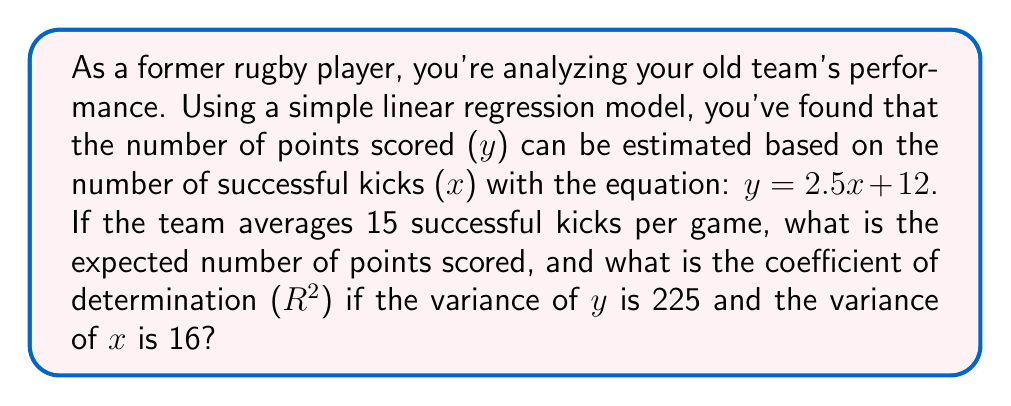Give your solution to this math problem. 1. Calculate the expected number of points:
   - Use the equation $y = 2.5x + 12$
   - Substitute $x = 15$ (average successful kicks)
   $$y = 2.5(15) + 12 = 37.5 + 12 = 49.5$$

2. Calculate the coefficient of determination ($R^2$):
   - The formula for $R^2$ in simple linear regression is:
     $$R^2 = \frac{(Cov(x,y))^2}{Var(x)Var(y)}$$

   - We know $Var(y) = 225$ and $Var(x) = 16$

   - To find $Cov(x,y)$, use the slope of the regression line:
     $$b_1 = \frac{Cov(x,y)}{Var(x)}$$
     $$2.5 = \frac{Cov(x,y)}{16}$$
     $$Cov(x,y) = 2.5 * 16 = 40$$

   - Now substitute into the $R^2$ formula:
     $$R^2 = \frac{40^2}{16 * 225} = \frac{1600}{3600} = \frac{4}{9} \approx 0.444$$
Answer: 49.5 points; $R^2 \approx 0.444$ 